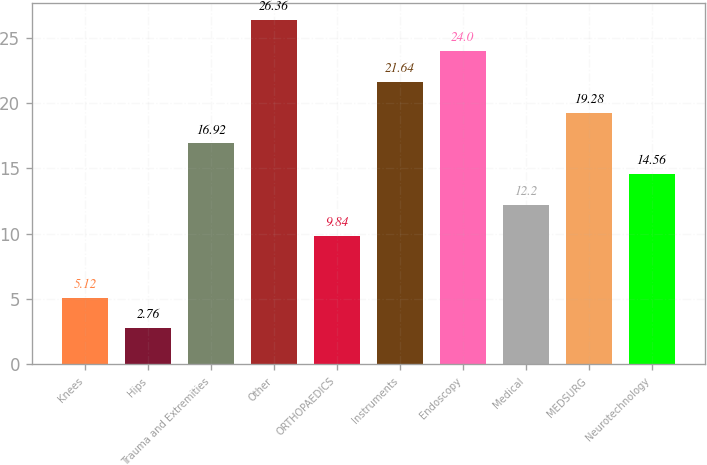<chart> <loc_0><loc_0><loc_500><loc_500><bar_chart><fcel>Knees<fcel>Hips<fcel>Trauma and Extremities<fcel>Other<fcel>ORTHOPAEDICS<fcel>Instruments<fcel>Endoscopy<fcel>Medical<fcel>MEDSURG<fcel>Neurotechnology<nl><fcel>5.12<fcel>2.76<fcel>16.92<fcel>26.36<fcel>9.84<fcel>21.64<fcel>24<fcel>12.2<fcel>19.28<fcel>14.56<nl></chart> 